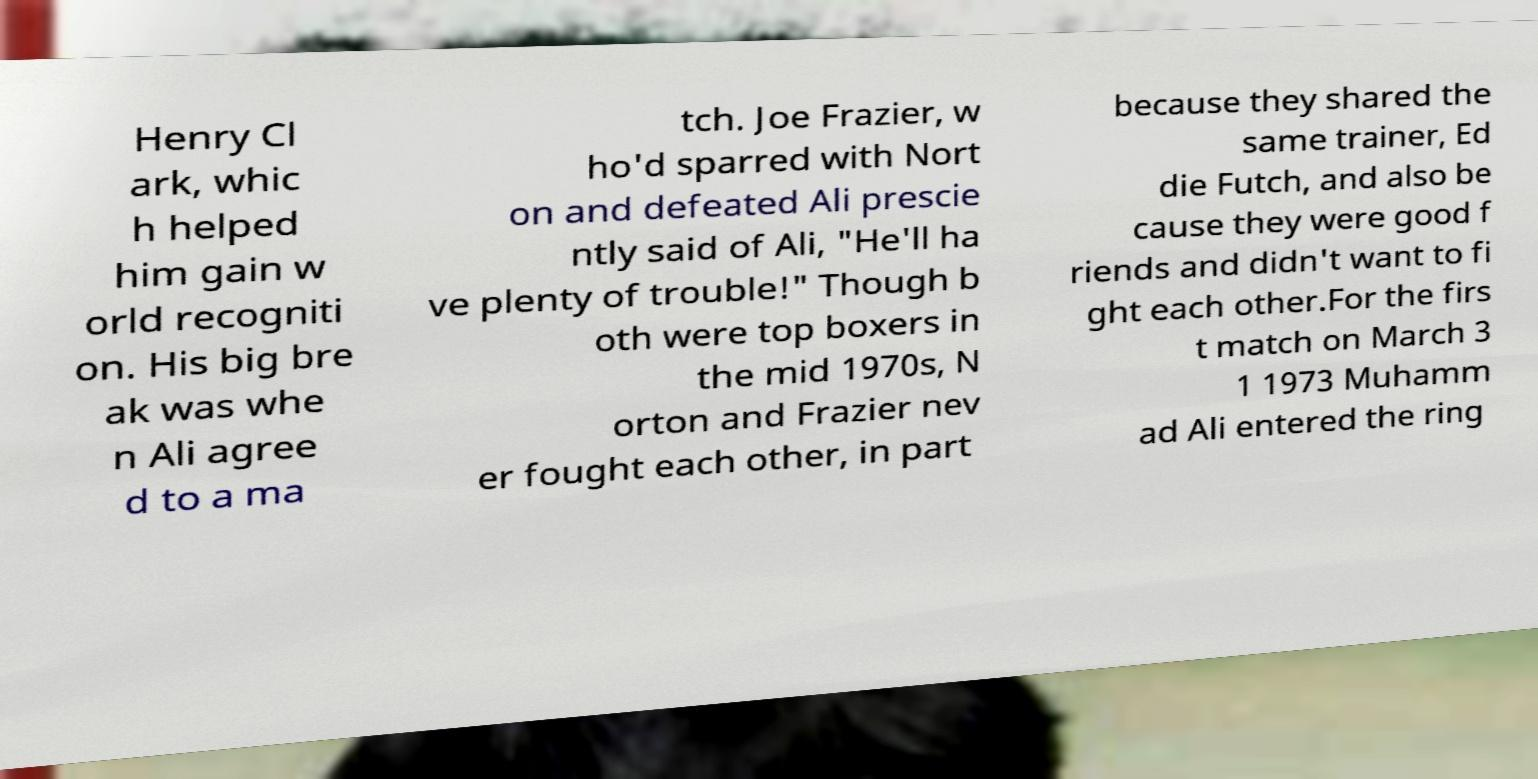Please identify and transcribe the text found in this image. Henry Cl ark, whic h helped him gain w orld recogniti on. His big bre ak was whe n Ali agree d to a ma tch. Joe Frazier, w ho'd sparred with Nort on and defeated Ali prescie ntly said of Ali, "He'll ha ve plenty of trouble!" Though b oth were top boxers in the mid 1970s, N orton and Frazier nev er fought each other, in part because they shared the same trainer, Ed die Futch, and also be cause they were good f riends and didn't want to fi ght each other.For the firs t match on March 3 1 1973 Muhamm ad Ali entered the ring 